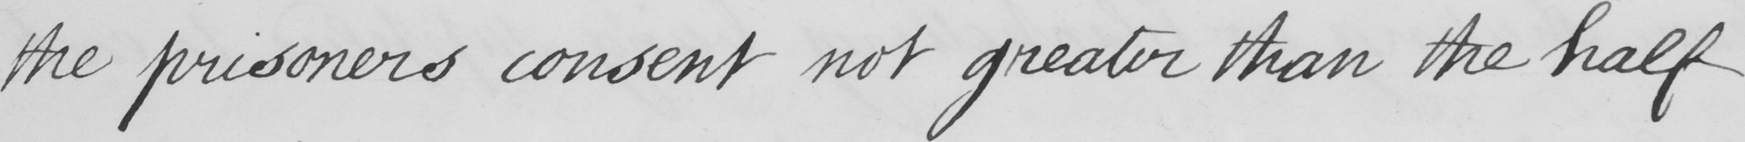Can you read and transcribe this handwriting? the prisoners consent not greater than the half 